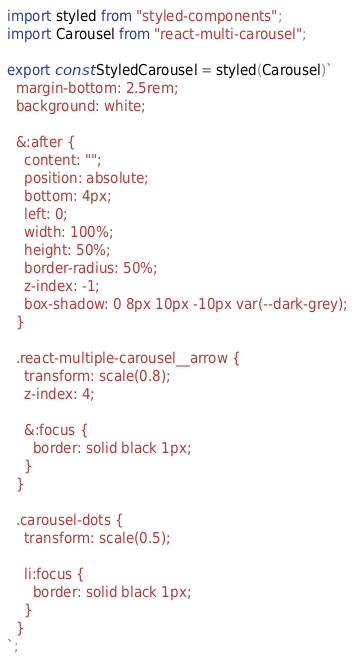Convert code to text. <code><loc_0><loc_0><loc_500><loc_500><_JavaScript_>import styled from "styled-components";
import Carousel from "react-multi-carousel";

export const StyledCarousel = styled(Carousel)`
  margin-bottom: 2.5rem;
  background: white;

  &:after {
    content: "";
    position: absolute;
    bottom: 4px;
    left: 0;
    width: 100%;
    height: 50%;
    border-radius: 50%;
    z-index: -1;
    box-shadow: 0 8px 10px -10px var(--dark-grey);
  }

  .react-multiple-carousel__arrow {
    transform: scale(0.8);
    z-index: 4;

    &:focus {
      border: solid black 1px;
    }
  }

  .carousel-dots {
    transform: scale(0.5);

    li:focus {
      border: solid black 1px;
    }
  }
`;
</code> 